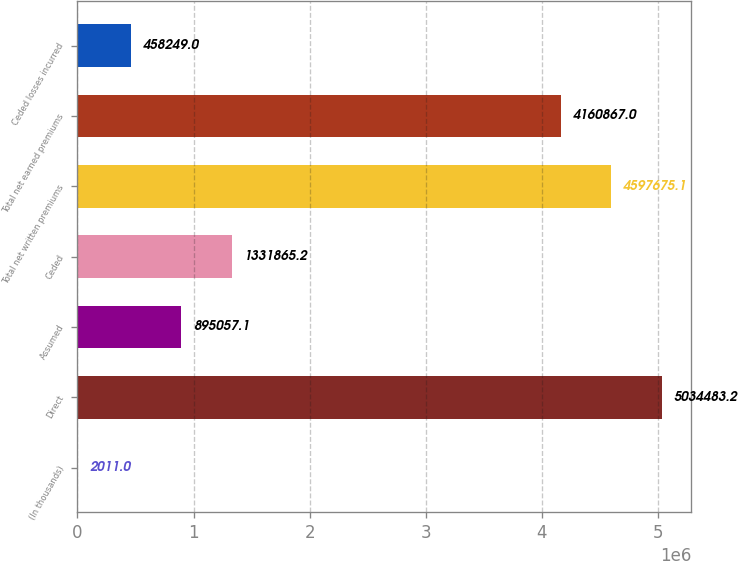Convert chart. <chart><loc_0><loc_0><loc_500><loc_500><bar_chart><fcel>(In thousands)<fcel>Direct<fcel>Assumed<fcel>Ceded<fcel>Total net written premiums<fcel>Total net earned premiums<fcel>Ceded losses incurred<nl><fcel>2011<fcel>5.03448e+06<fcel>895057<fcel>1.33187e+06<fcel>4.59768e+06<fcel>4.16087e+06<fcel>458249<nl></chart> 